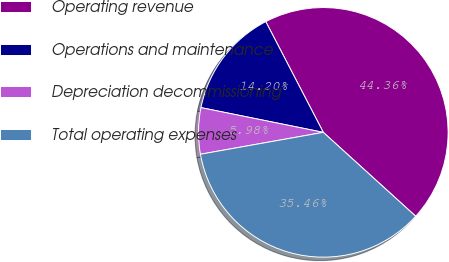Convert chart to OTSL. <chart><loc_0><loc_0><loc_500><loc_500><pie_chart><fcel>Operating revenue<fcel>Operations and maintenance<fcel>Depreciation decommissioning<fcel>Total operating expenses<nl><fcel>44.36%<fcel>14.2%<fcel>5.98%<fcel>35.46%<nl></chart> 